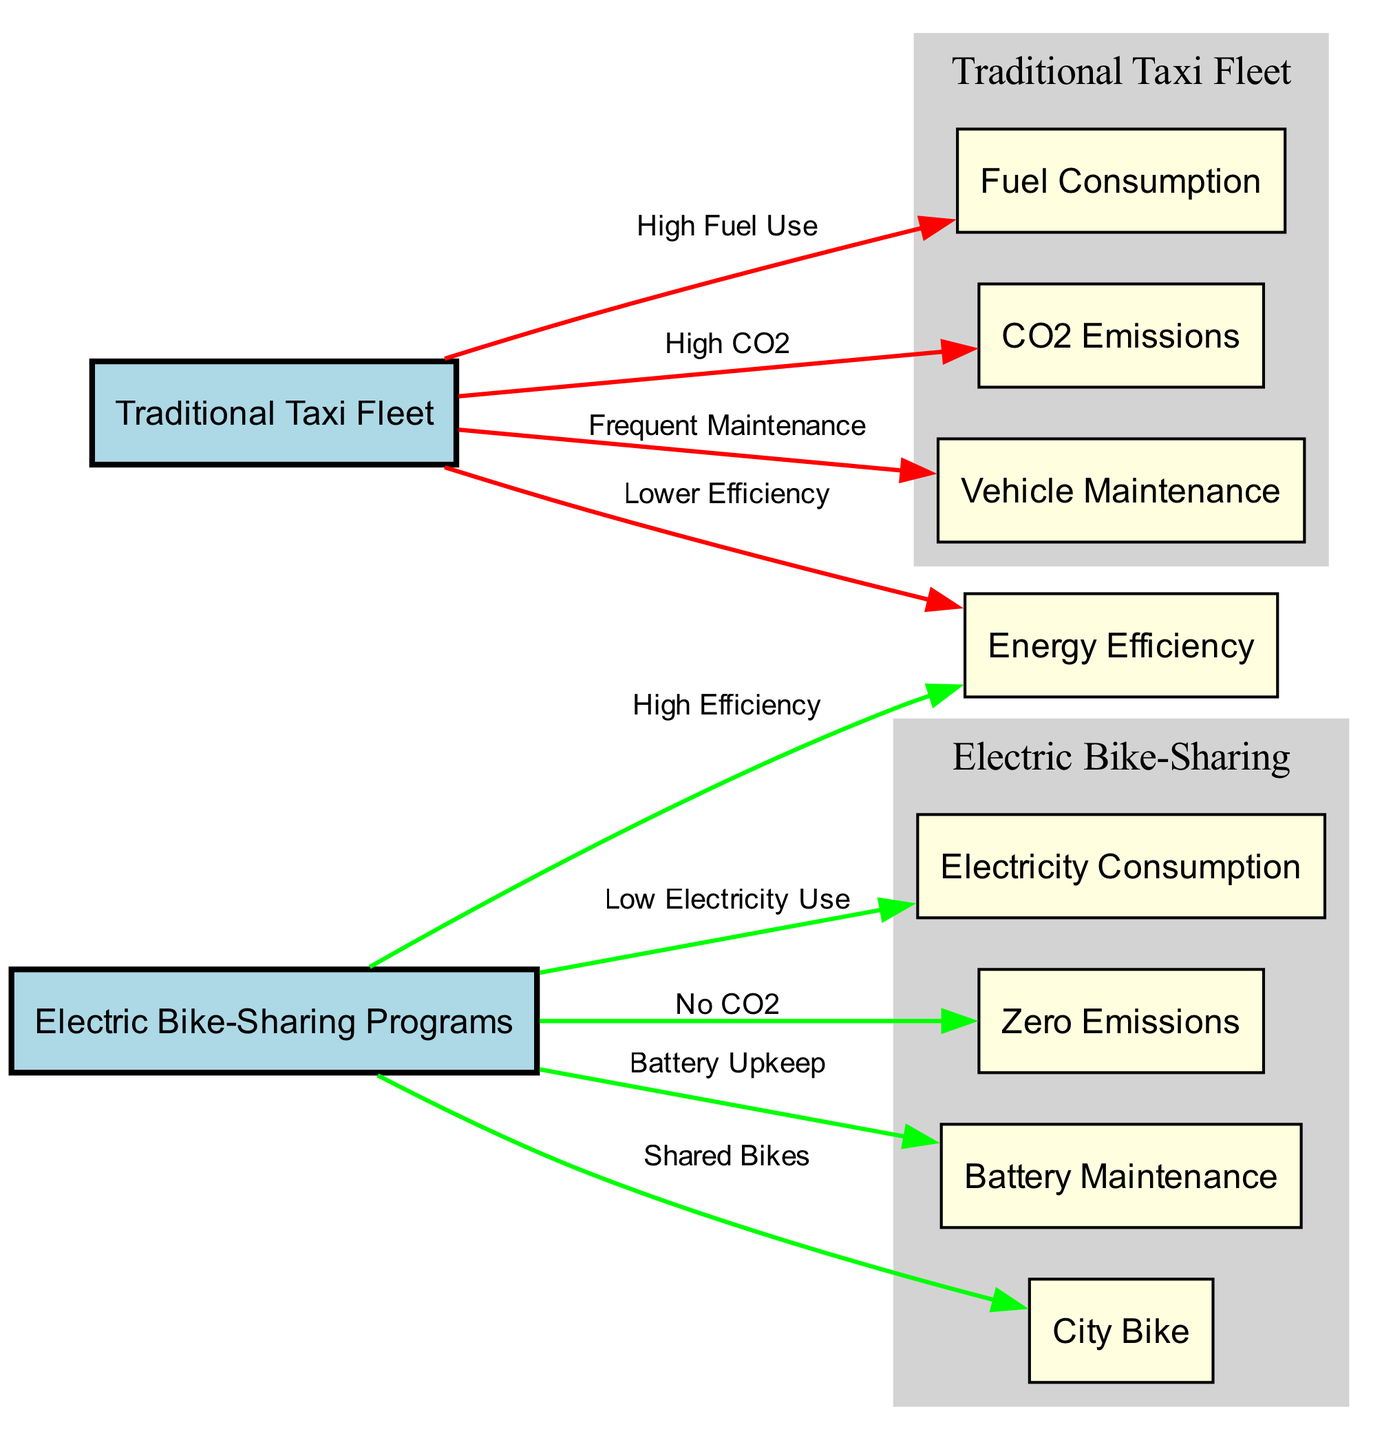What is the color of the traditional taxi fleet node? The node representing the traditional taxi fleet is colored light blue, indicating its significant role in the diagram compared to other nodes, thus standing out.
Answer: light blue How many edges connect to the electric bike-sharing node? There are four edges originating from the electric bike-sharing node, linking it to electricity consumption, zero emissions, battery maintenance, and city bike.
Answer: four What does the edge labeled “High CO2” indicate? The edge labeled “High CO2” originates from the traditional taxi fleet and leads to the CO2 emissions node, indicating that the taxi fleet produces a significant amount of carbon dioxide emissions.
Answer: High CO2 Which program is indicated as having zero emissions? The electric bike-sharing program is indicated to have zero emissions, as shown by the edge from this node to the zero emissions node.
Answer: electric bike-sharing programs What maintenance type is associated with the traditional taxi fleet? The traditional taxi fleet is associated with frequent maintenance, as indicated by the edge from this node to the vehicle maintenance node labeled “Frequent Maintenance.”
Answer: Frequent Maintenance Compare the energy efficiency between both programs. The diagram shows that the traditional taxi fleet has lower efficiency, while the electric bike-sharing programs exhibit high efficiency, revealing a significant difference in energy use between them.
Answer: High Efficiency vs. Lower Efficiency How does the electricity consumption of electric bike-sharing compare to fuel consumption of traditional taxis? The electric bike-sharing program has low electricity use, in stark contrast to the traditional taxi fleet which has high fuel use, thus revealing differing energy consumption patterns between the two.
Answer: Low Electricity Use vs. High Fuel Use Which node represents bike-sharing? The node that represents bike-sharing is "City Bike," which is linked to the electric bike-sharing program, illustrating the shared nature of the bike program.
Answer: City Bike What is the implication of the “Battery Upkeep” connection in electric bike-sharing? The edge labeled “Battery Upkeep” indicates that while electric bike-sharing has low electricity use, it still requires maintenance for battery systems, highlighting the operational needs associated with this energy-efficient mode.
Answer: Battery Maintenance 